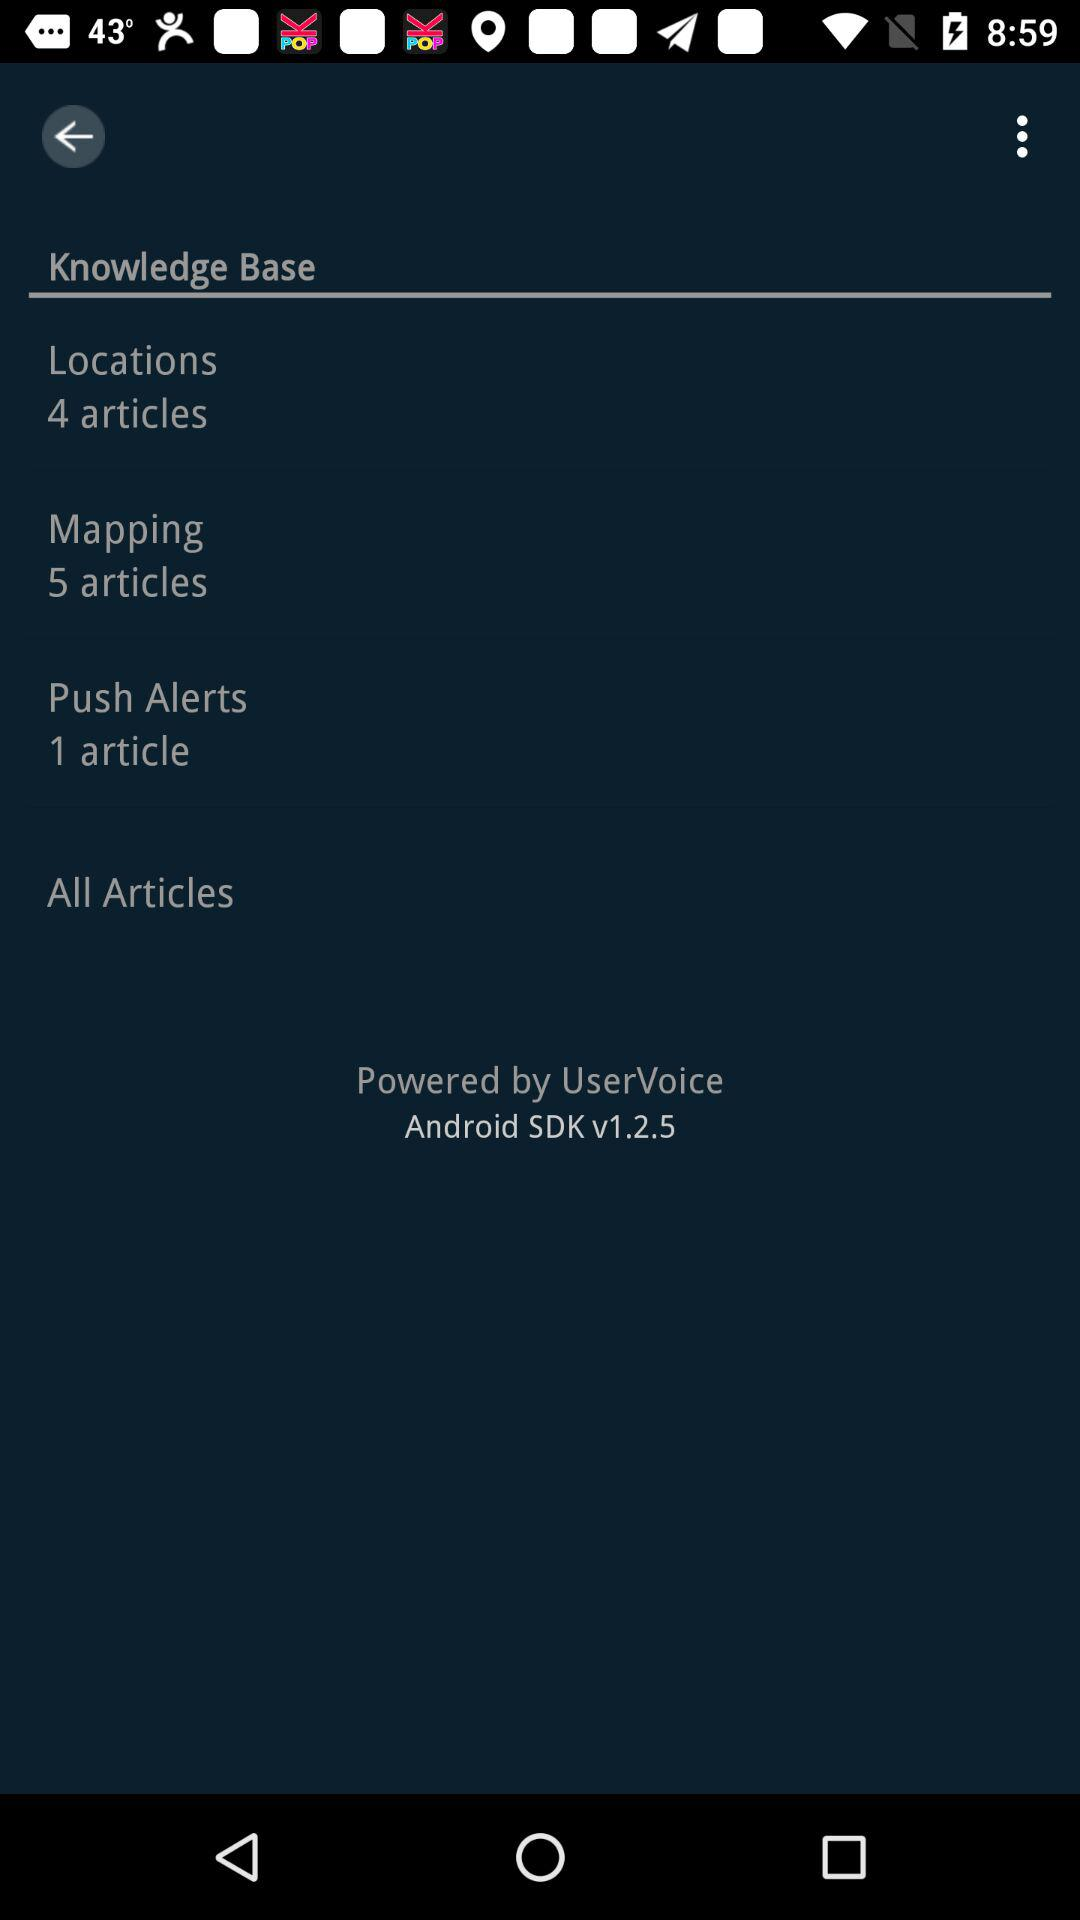What is the number of articles in push alerts? The number of articles in push alerts is 1. 